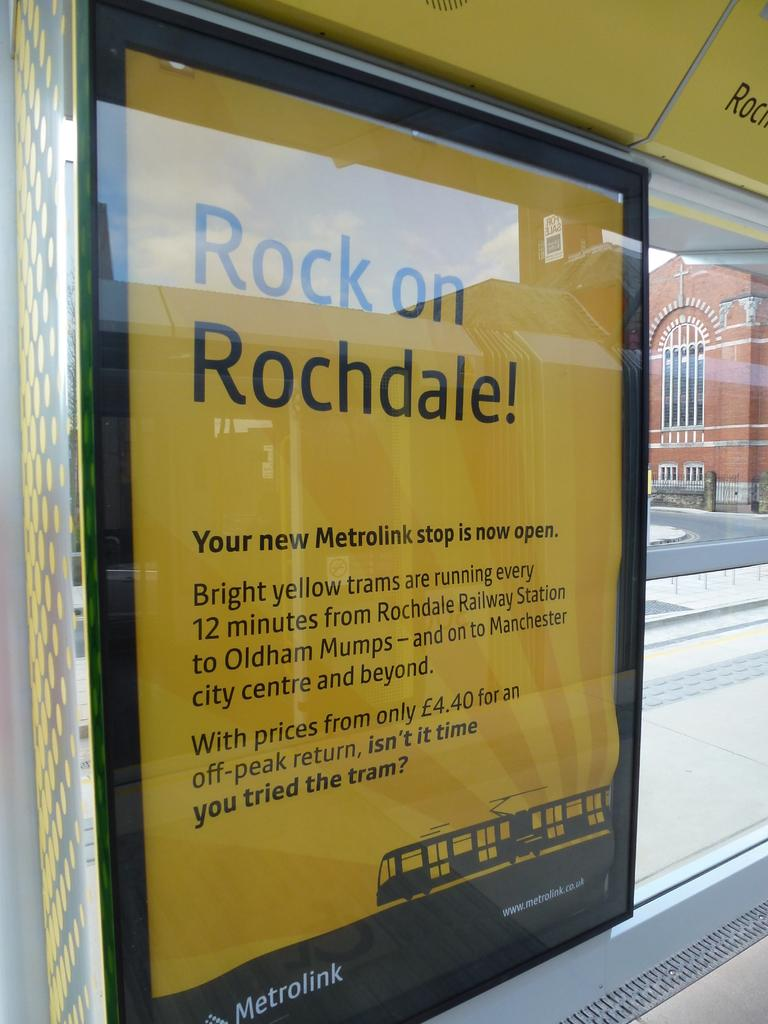What is the main object in the image? There is a board in the image. What can be seen in the distance behind the board? There is a building and a road in the background of the image. Can you see any bikes or fire near the ocean in the image? There is no ocean, bikes, or fire present in the image. 